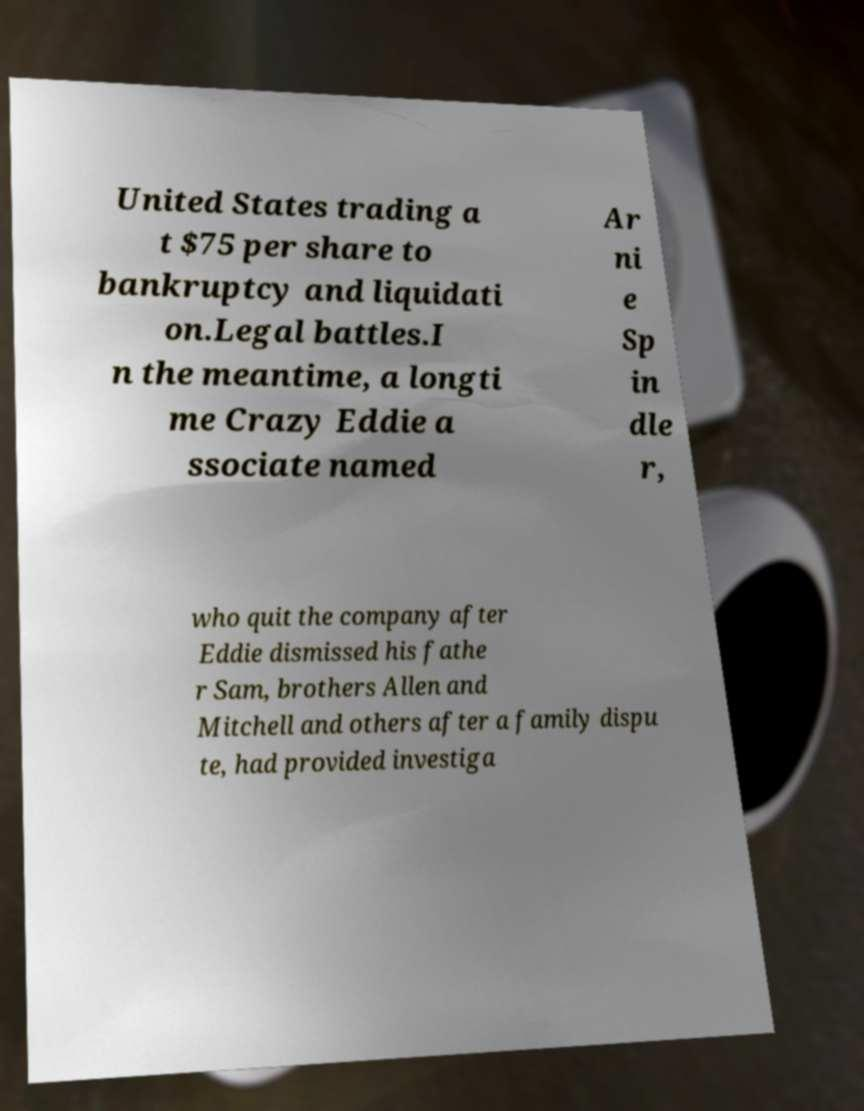Can you accurately transcribe the text from the provided image for me? United States trading a t $75 per share to bankruptcy and liquidati on.Legal battles.I n the meantime, a longti me Crazy Eddie a ssociate named Ar ni e Sp in dle r, who quit the company after Eddie dismissed his fathe r Sam, brothers Allen and Mitchell and others after a family dispu te, had provided investiga 